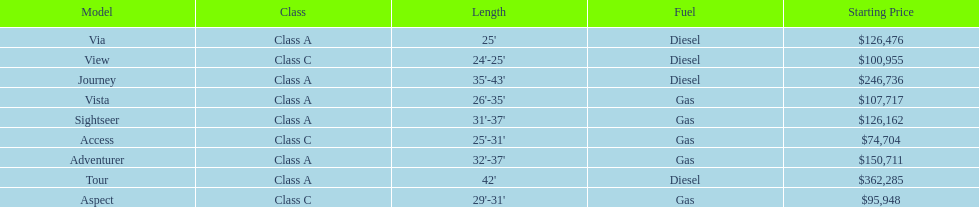Which model is at the top of the list with the highest starting price? Tour. 